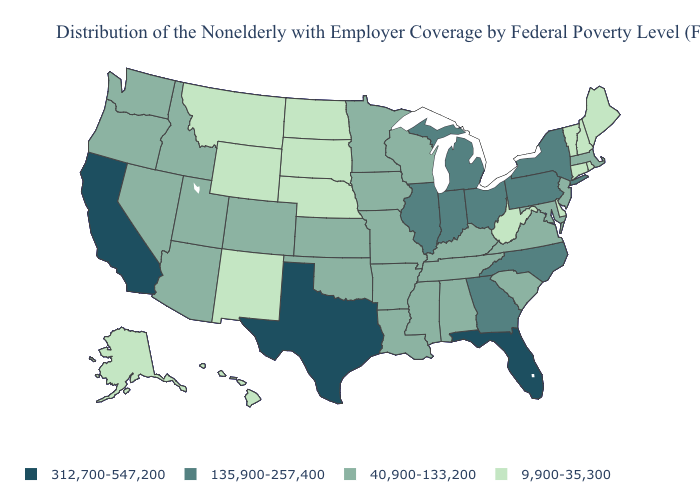What is the value of Louisiana?
Be succinct. 40,900-133,200. Name the states that have a value in the range 312,700-547,200?
Be succinct. California, Florida, Texas. What is the value of Vermont?
Keep it brief. 9,900-35,300. Which states have the highest value in the USA?
Concise answer only. California, Florida, Texas. Name the states that have a value in the range 40,900-133,200?
Short answer required. Alabama, Arizona, Arkansas, Colorado, Idaho, Iowa, Kansas, Kentucky, Louisiana, Maryland, Massachusetts, Minnesota, Mississippi, Missouri, Nevada, New Jersey, Oklahoma, Oregon, South Carolina, Tennessee, Utah, Virginia, Washington, Wisconsin. What is the value of Texas?
Keep it brief. 312,700-547,200. What is the lowest value in states that border Connecticut?
Be succinct. 9,900-35,300. Does the map have missing data?
Write a very short answer. No. Does North Carolina have the highest value in the USA?
Short answer required. No. What is the value of Ohio?
Short answer required. 135,900-257,400. What is the lowest value in the USA?
Concise answer only. 9,900-35,300. What is the value of Idaho?
Answer briefly. 40,900-133,200. Does Indiana have the same value as Wisconsin?
Answer briefly. No. Among the states that border Wisconsin , which have the highest value?
Quick response, please. Illinois, Michigan. What is the value of North Dakota?
Give a very brief answer. 9,900-35,300. 